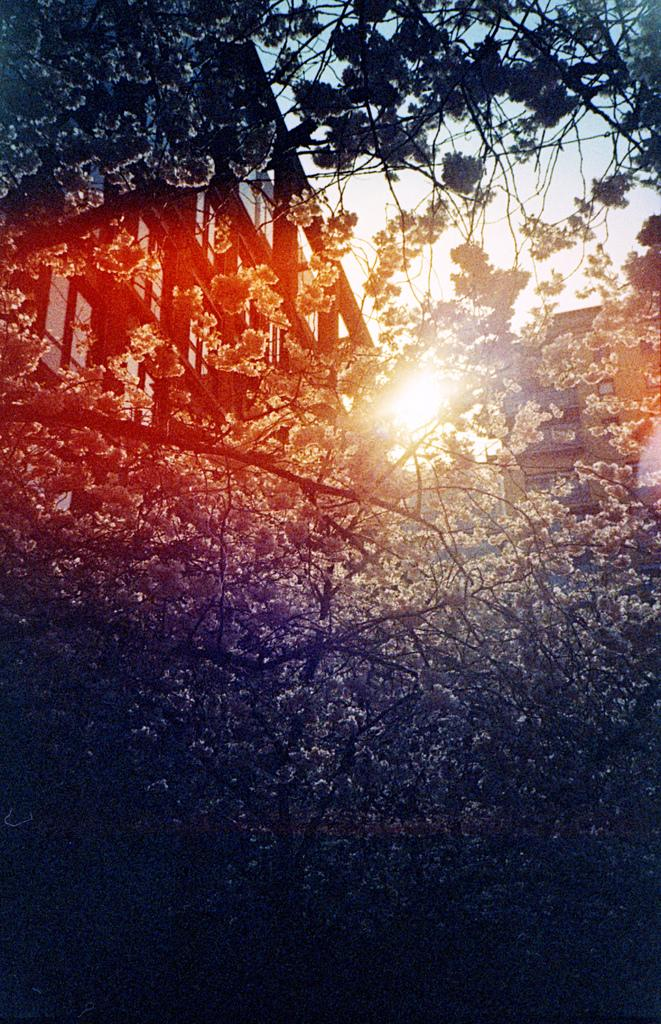What type of natural elements can be seen in the image? The image contains trees. What celestial body is present in the image? There is a sun in the middle of the image. What part of the natural environment is visible in the image? The sky is visible at the top of the image. What type of cake is being served to the family on the boats in the image? There is no family, boats, or cake present in the image; it only contains trees, a sun, and the sky. 